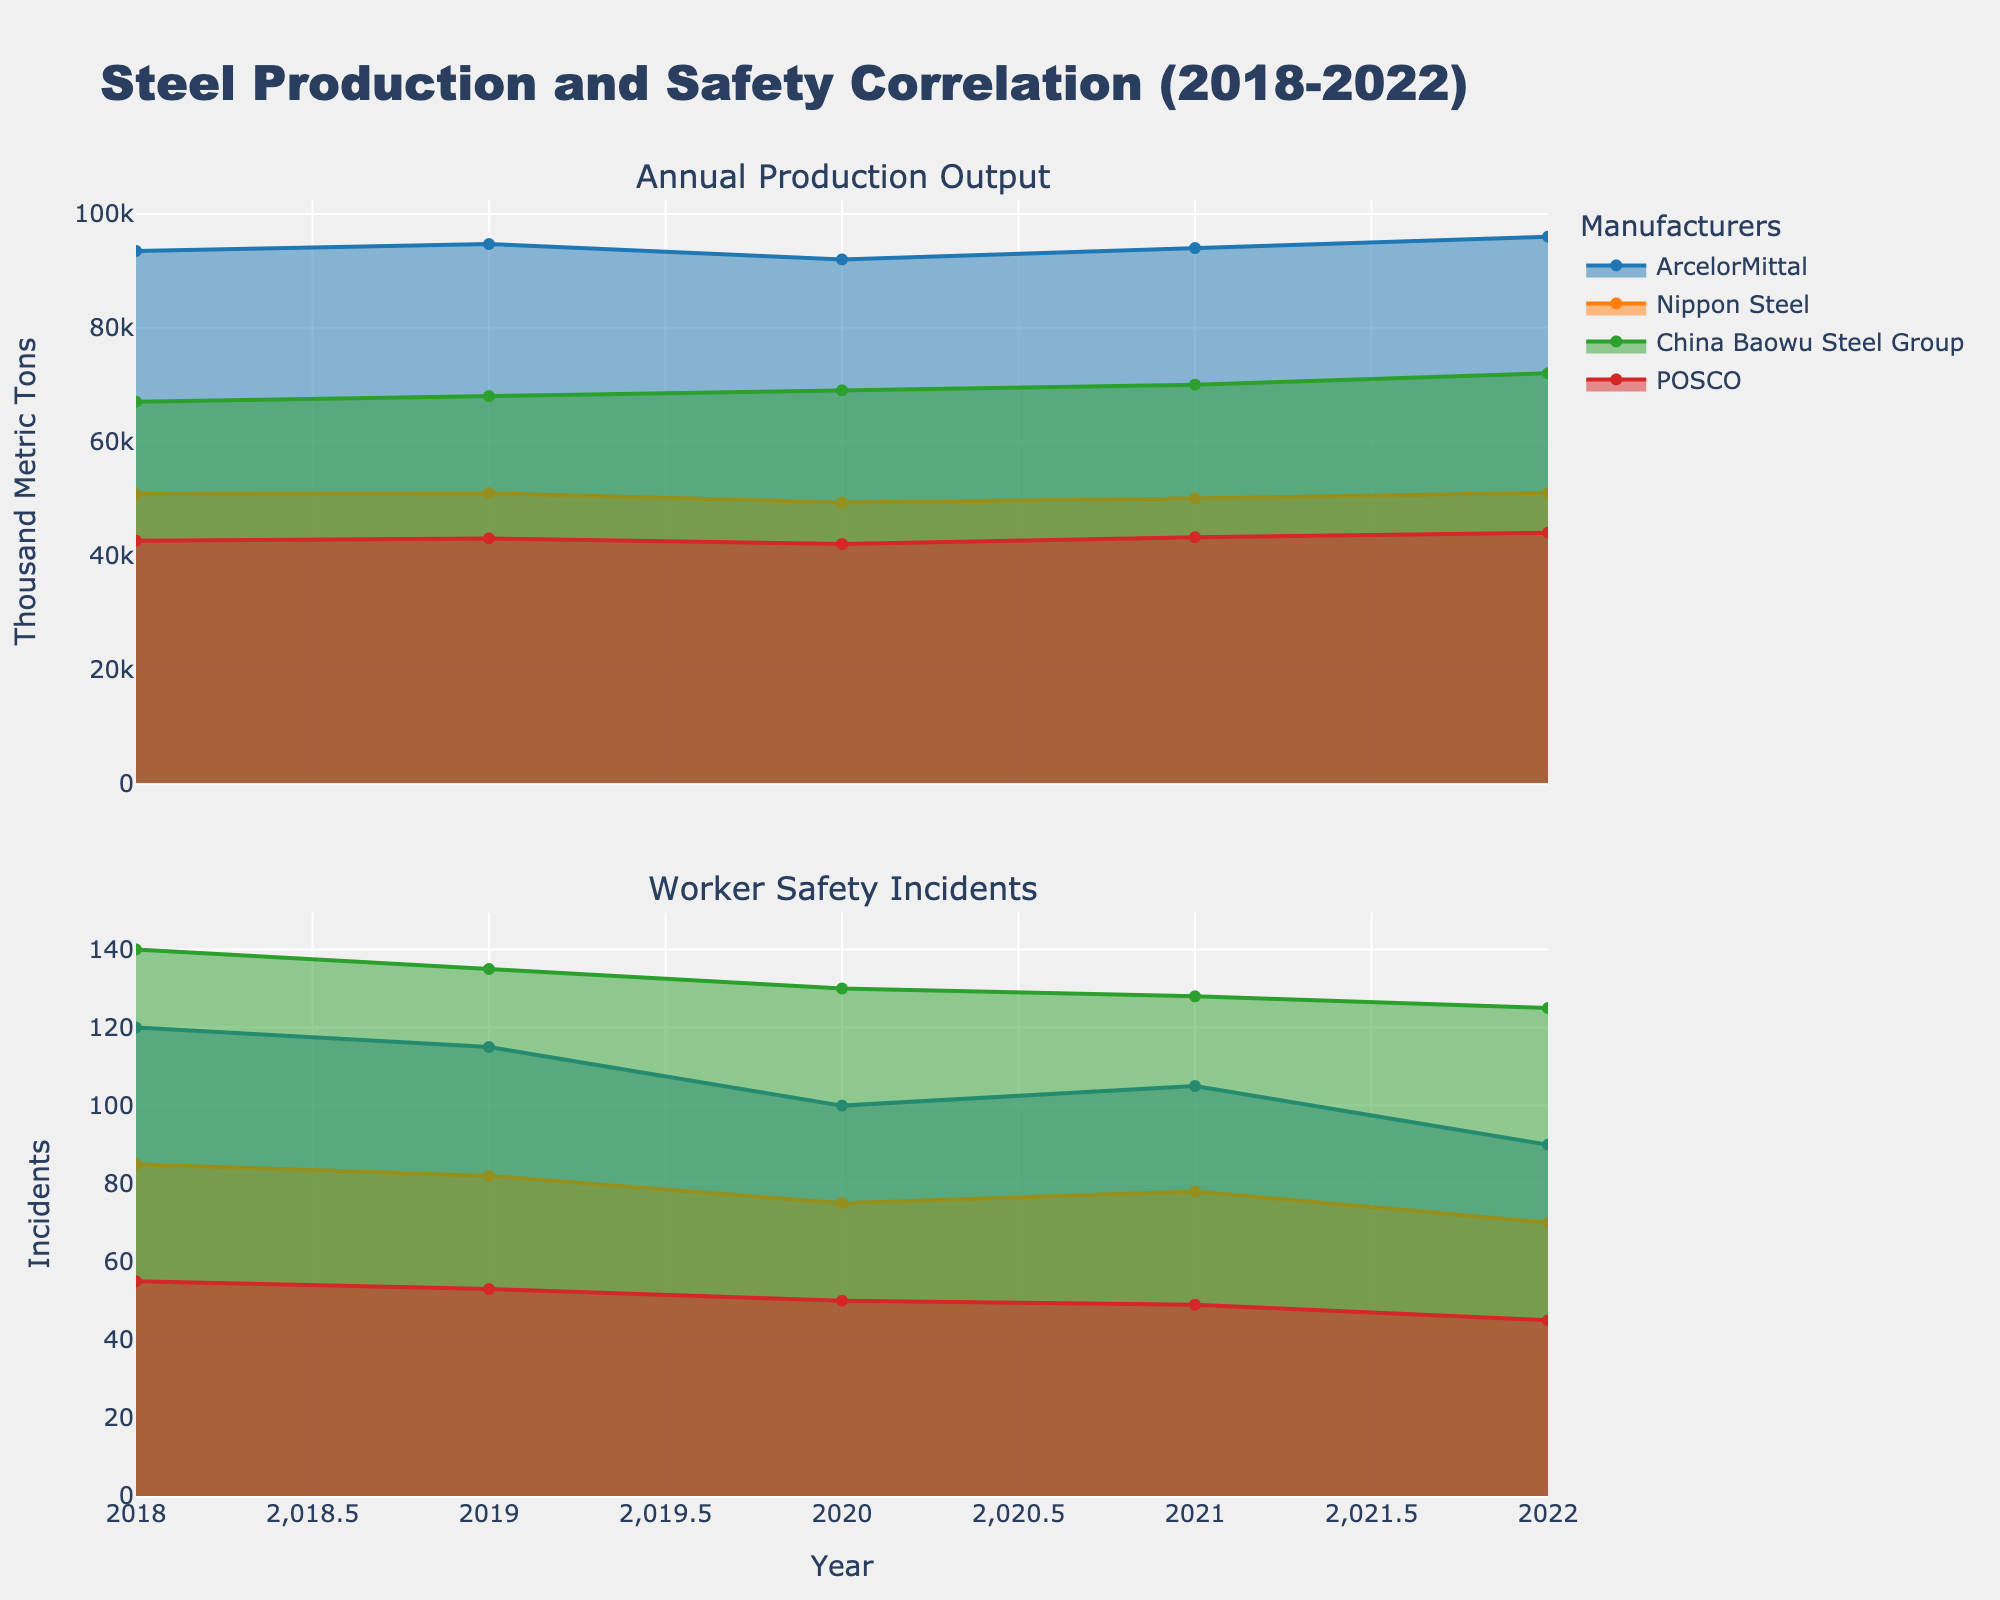what is the main title of the plot? The main title of the plot is positioned at the top and is usually the largest text on the figure. By directly reading it, we see it is "Steel Production and Safety Correlation (2018-2022)"
Answer: Steel Production and Safety Correlation (2018-2022) What's the total Worker Safety Incidents for ArcelorMittal in 2020 and 2021? Adding the incidents for ArcelorMittal in those two years, which are 100 and 105: 100 + 105 = 205
Answer: 205 Which manufacturer had the highest Annual Production Output in 2022? Checking the 2022 data points, ArcelorMittal had the highest value with 96,000 thousand metric tons
Answer: ArcelorMittal How did Worker Safety Incidents for POSCO change from 2018 to 2022? By observing the change in values for those years (55, 53, 50, 49, 45), we see a consistent decrease in incidents over time
Answer: Decreased Compare the Worker Safety Incidents of Nippon Steel and China Baowu Steel Group in 2019. Which had more incidents? In 2019, Nippon Steel had 82 incidents while China Baowu Steel Group had 135, so China Baowu had more incidents
Answer: China Baowu Steel Group What's the trend in Annual Production Output for Nippon Steel from 2018 to 2022? Observing the values (50,800, 50,950, 49,300, 50,000, 51,000), there is a slight increase with a dip in 2020
Answer: Slightly increasing with a dip in 2020 What is the difference in Worker Safety Incidents between the highest and lowest values for ArcelorMittal during 2018-2022? The highest value is 120 in 2018 and the lowest is 90 in 2022; calculating the difference: 120 - 90 = 30
Answer: 30 Which manufacturer showed the most consistent decreasing trend in Worker Safety Incidents from 2018 to 2022? POSCO incidents from 2018 to 2022 (55, 53, 50, 49, 45) show a constant decrease, indicating the most consistent trend
Answer: POSCO What's the average Annual Production Output for China Baowu Steel Group over the 5 years? Adding the annual production values for China Baowu (67,000, 68,000, 69,000, 70,000, 72,000) and dividing by 5, we get (67,000 + 68,000 + 69,000 + 70,000 + 72,000) / 5 = 69,200
Answer: 69,200 